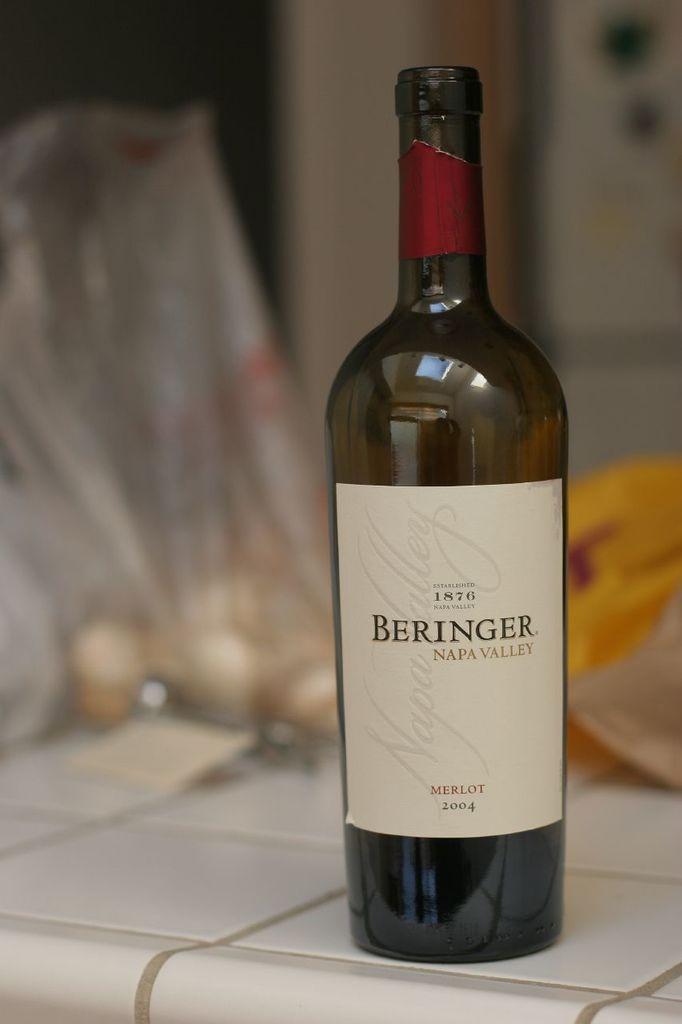Is this a merlot?
Keep it short and to the point. Yes. When was the wine bottled?
Ensure brevity in your answer.  2004. 